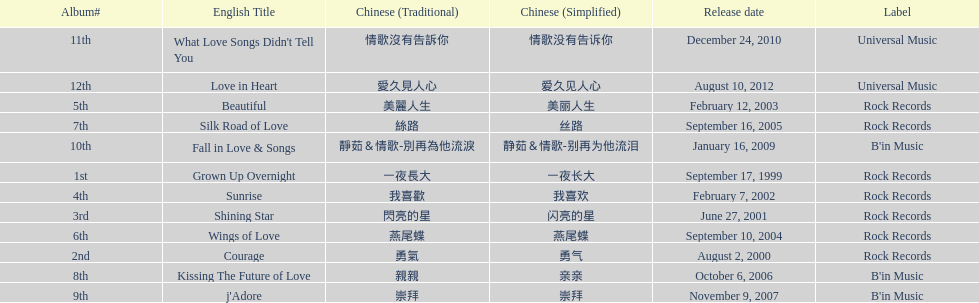Which was the only album to be released by b'in music in an even-numbered year? Kissing The Future of Love. 